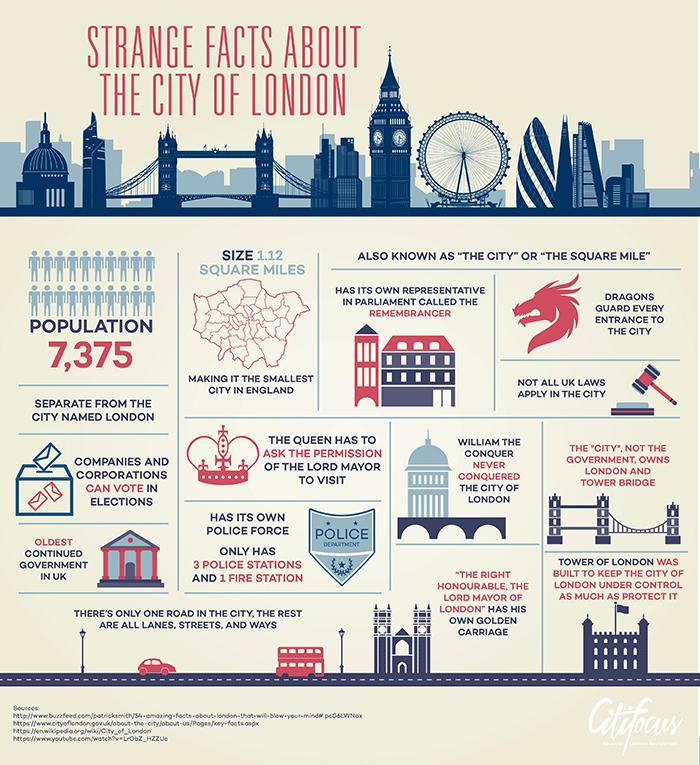List a handful of essential elements in this visual. Who owns London and Tower Bridge? The City does. The area of the City of London is 1.12 square miles. The Tower of London was constructed to secure and govern the City of London. Legendary dragons are the guardians of each city entrance, imparting a sense of awe and reverence to all who approach. The Queen requires the Lord Mayor of London's permission to visit the city. 